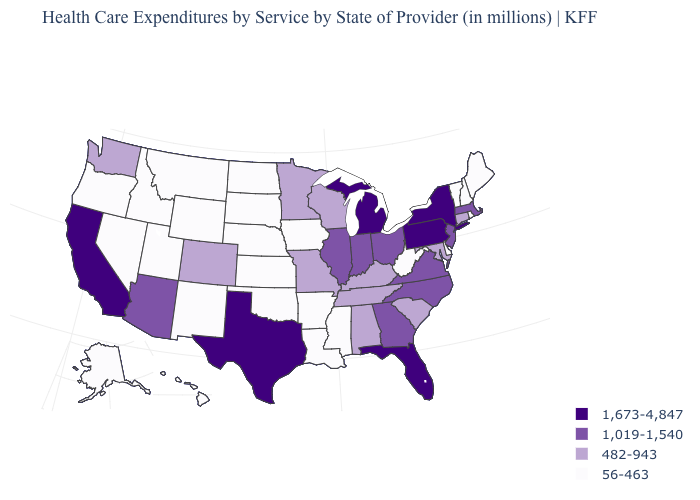What is the value of South Carolina?
Give a very brief answer. 482-943. What is the value of Ohio?
Quick response, please. 1,019-1,540. What is the value of Michigan?
Quick response, please. 1,673-4,847. Which states have the lowest value in the USA?
Write a very short answer. Alaska, Arkansas, Delaware, Hawaii, Idaho, Iowa, Kansas, Louisiana, Maine, Mississippi, Montana, Nebraska, Nevada, New Hampshire, New Mexico, North Dakota, Oklahoma, Oregon, Rhode Island, South Dakota, Utah, Vermont, West Virginia, Wyoming. Among the states that border New Jersey , which have the highest value?
Keep it brief. New York, Pennsylvania. What is the value of Missouri?
Be succinct. 482-943. Name the states that have a value in the range 1,673-4,847?
Short answer required. California, Florida, Michigan, New York, Pennsylvania, Texas. Does Indiana have a higher value than Michigan?
Quick response, please. No. What is the highest value in states that border Ohio?
Quick response, please. 1,673-4,847. Among the states that border Wisconsin , does Michigan have the highest value?
Quick response, please. Yes. What is the lowest value in the USA?
Give a very brief answer. 56-463. Which states hav the highest value in the Northeast?
Give a very brief answer. New York, Pennsylvania. Among the states that border Washington , which have the lowest value?
Keep it brief. Idaho, Oregon. Does New Jersey have the highest value in the USA?
Quick response, please. No. What is the lowest value in states that border Virginia?
Be succinct. 56-463. 